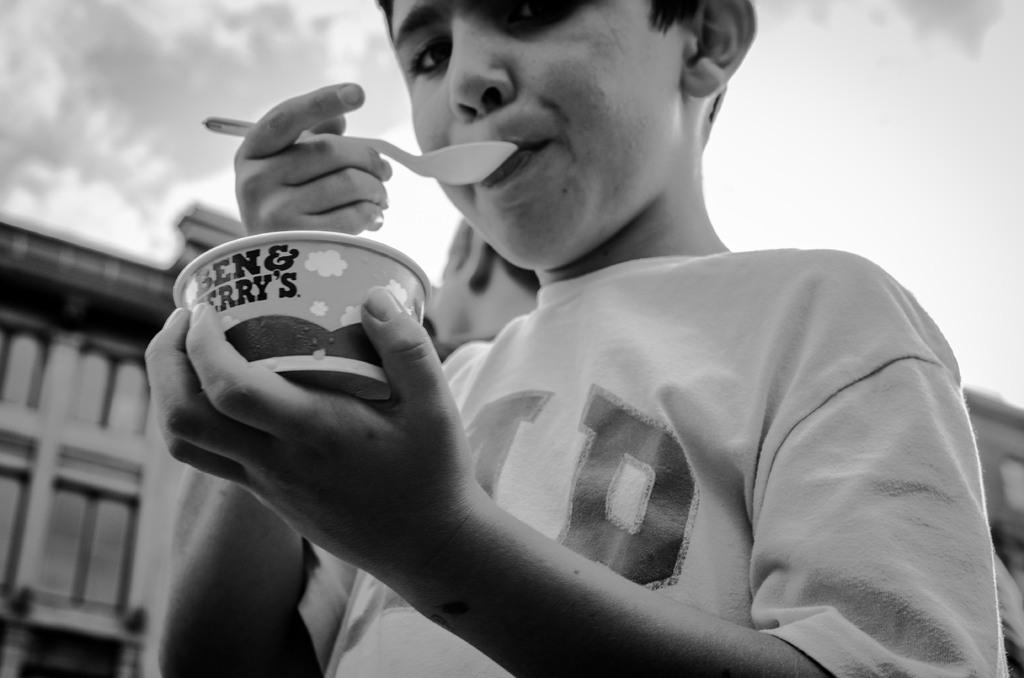What is the main subject in the foreground of the image? There is a boy in the foreground of the image. What is the boy holding in his hand? The boy is holding an ice cream bowl in his hand. What utensil is the boy using to eat the ice cream? The boy is holding a spoon. What can be seen in the background of the image? There are buildings and the sky visible in the background of the image. Can you describe the setting where the image was taken? The image may have been taken on a road, as suggested by the presence of buildings and the open sky. What type of sink can be seen in the image? There is no sink present in the image. How does the boy's sense of taste contribute to his enjoyment of the ice cream? The image does not provide information about the boy's sense of taste or his enjoyment of the ice cream. 